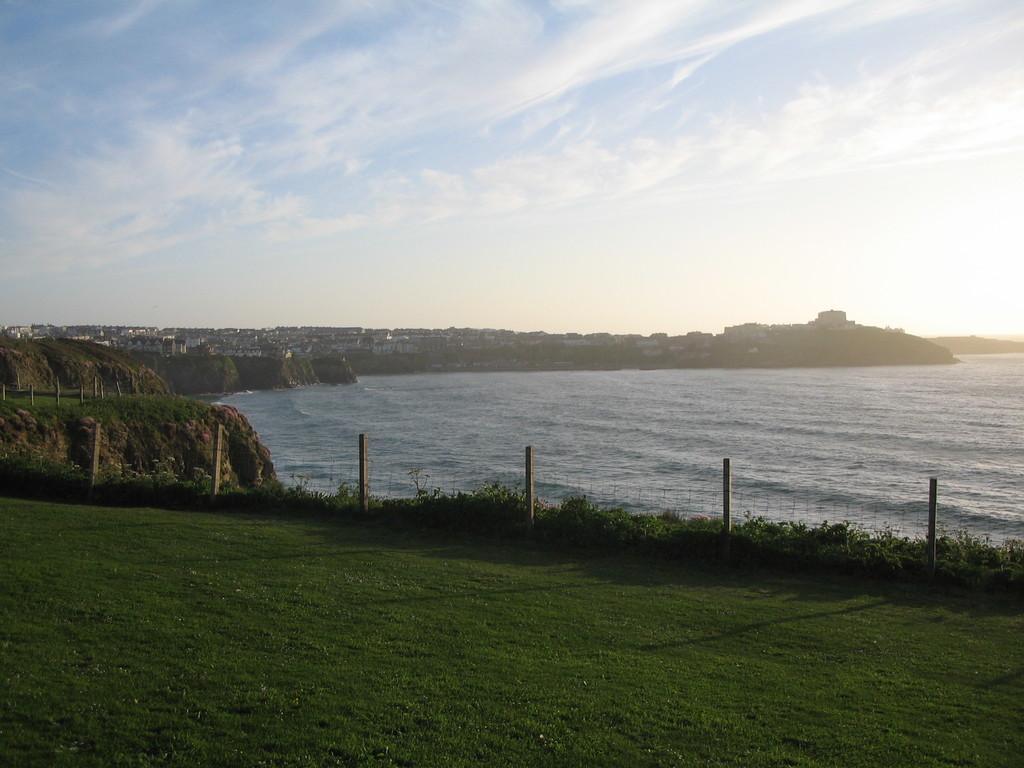Can you describe this image briefly? In this picture there is grassland and small bamboos at the bottom side of the image, it seems to be there is a river in the center of the image and there are buildings and greenery in the background area of the image and there is sky at the top side of the image. 